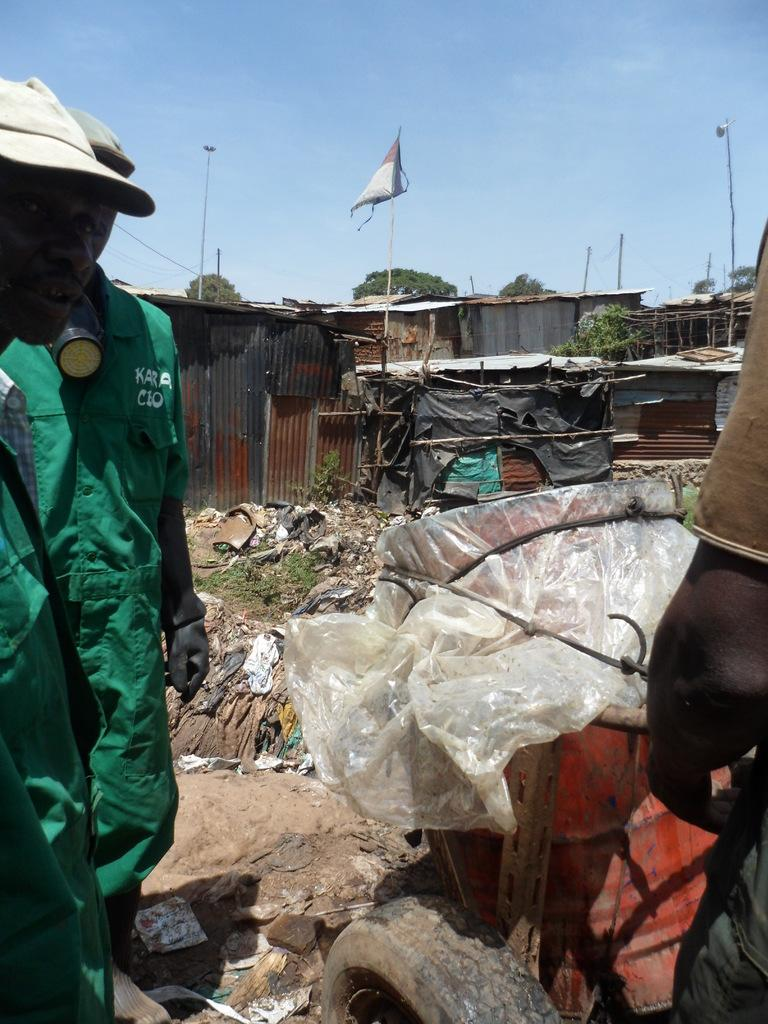What type of structures can be seen in the image? There are houses in the image. What type of vegetation is present in the image? There are trees in the image. What are the poles in the image used for? The poles in the image are likely used for supporting lights or other objects. What can be seen attached to the poles? There are lights in the image attached to the poles. Who or what else is present in the image? There are people in the image. What is the flag in the image associated with? The flag in the image may represent a country, organization, or event. What other objects can be seen on the ground in the image? There are other objects on the ground in the image, but their specific nature is not mentioned in the facts. What is visible in the background of the image? The sky is visible in the background of the image. What can be seen in the sky? There are clouds in the sky. What type of paste is being used by the hand in the image? There is no hand or paste present in the image. What is the aftermath of the event depicted in the image? There is no event or aftermath mentioned in the image; it simply shows houses, trees, poles, lights, people, a flag, other objects on the ground, and the sky with clouds. 